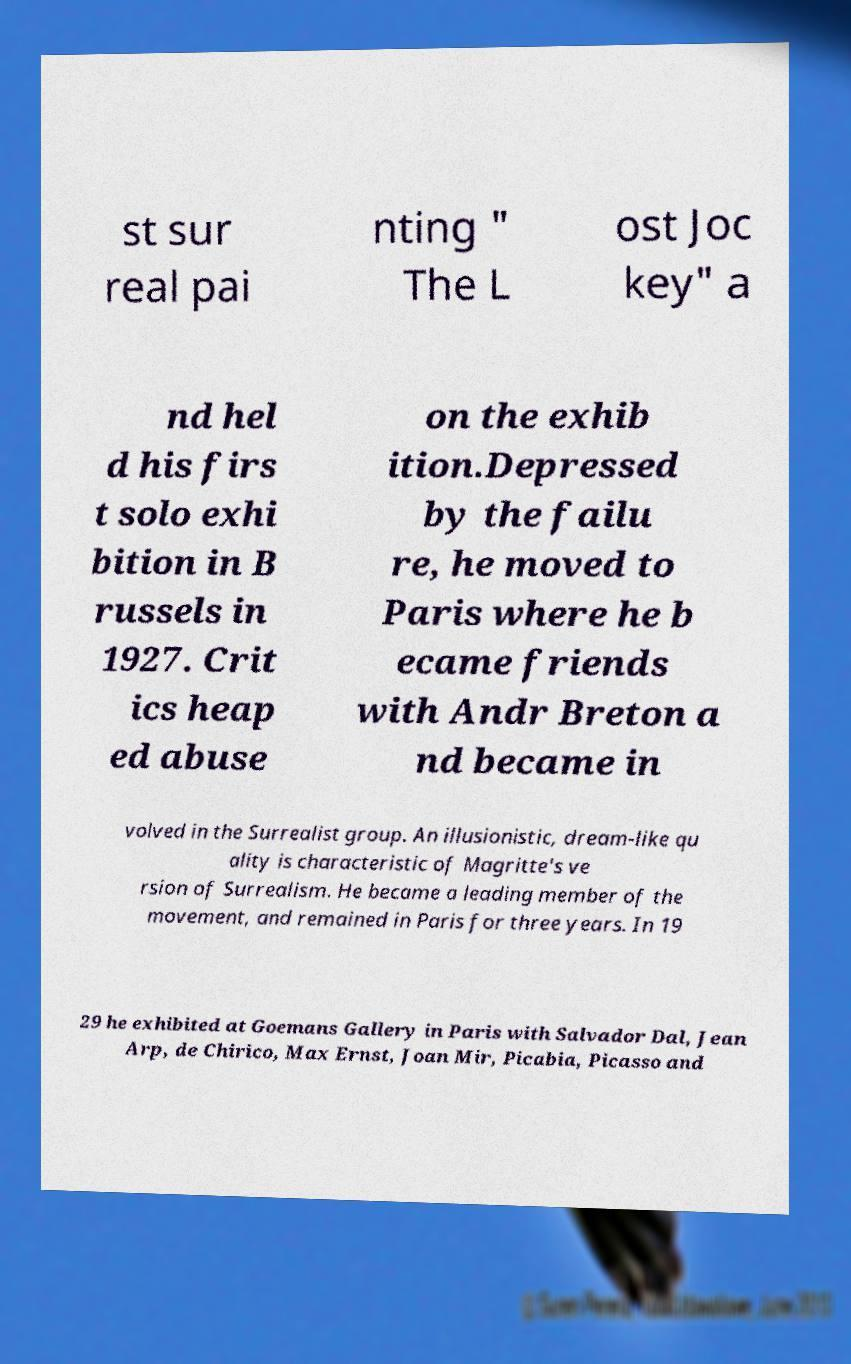For documentation purposes, I need the text within this image transcribed. Could you provide that? st sur real pai nting " The L ost Joc key" a nd hel d his firs t solo exhi bition in B russels in 1927. Crit ics heap ed abuse on the exhib ition.Depressed by the failu re, he moved to Paris where he b ecame friends with Andr Breton a nd became in volved in the Surrealist group. An illusionistic, dream-like qu ality is characteristic of Magritte's ve rsion of Surrealism. He became a leading member of the movement, and remained in Paris for three years. In 19 29 he exhibited at Goemans Gallery in Paris with Salvador Dal, Jean Arp, de Chirico, Max Ernst, Joan Mir, Picabia, Picasso and 